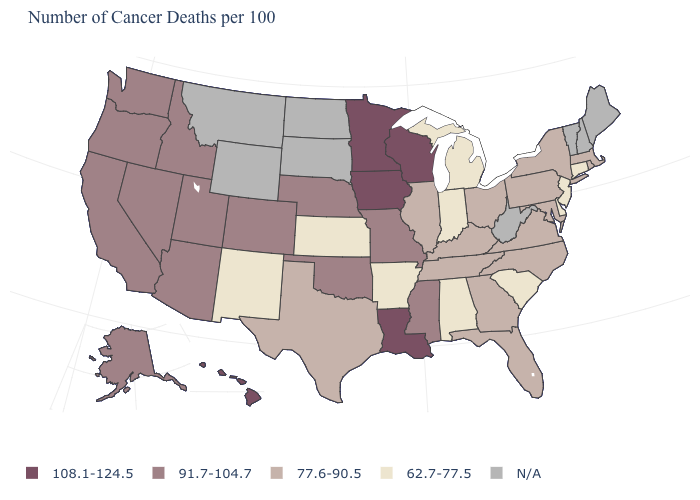Name the states that have a value in the range 77.6-90.5?
Concise answer only. Florida, Georgia, Illinois, Kentucky, Maryland, Massachusetts, New York, North Carolina, Ohio, Pennsylvania, Rhode Island, Tennessee, Texas, Virginia. Name the states that have a value in the range 62.7-77.5?
Answer briefly. Alabama, Arkansas, Connecticut, Delaware, Indiana, Kansas, Michigan, New Jersey, New Mexico, South Carolina. What is the value of Virginia?
Quick response, please. 77.6-90.5. Which states hav the highest value in the West?
Keep it brief. Hawaii. What is the value of Iowa?
Short answer required. 108.1-124.5. Which states have the highest value in the USA?
Short answer required. Hawaii, Iowa, Louisiana, Minnesota, Wisconsin. What is the value of Wyoming?
Short answer required. N/A. What is the value of Washington?
Quick response, please. 91.7-104.7. What is the value of Tennessee?
Give a very brief answer. 77.6-90.5. Among the states that border Kansas , which have the highest value?
Write a very short answer. Colorado, Missouri, Nebraska, Oklahoma. Name the states that have a value in the range 62.7-77.5?
Concise answer only. Alabama, Arkansas, Connecticut, Delaware, Indiana, Kansas, Michigan, New Jersey, New Mexico, South Carolina. Name the states that have a value in the range 108.1-124.5?
Answer briefly. Hawaii, Iowa, Louisiana, Minnesota, Wisconsin. Does Louisiana have the highest value in the South?
Quick response, please. Yes. What is the value of South Carolina?
Be succinct. 62.7-77.5. 